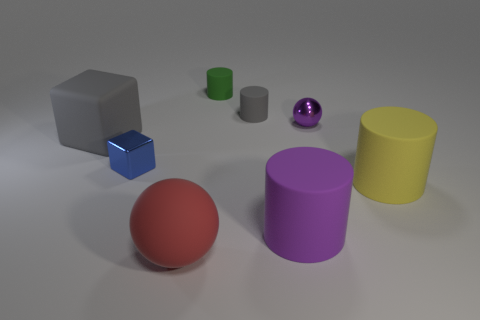Is the shape of the small matte object that is behind the small gray object the same as the tiny shiny thing on the left side of the gray matte cylinder?
Make the answer very short. No. There is a gray matte thing that is the same size as the blue metal thing; what is its shape?
Your response must be concise. Cylinder. What color is the big block that is made of the same material as the red sphere?
Offer a very short reply. Gray. Does the red matte object have the same shape as the metallic object that is on the right side of the big red matte thing?
Provide a short and direct response. Yes. There is a tiny cylinder that is the same color as the large block; what is its material?
Your answer should be very brief. Rubber. There is a gray cylinder that is the same size as the green matte cylinder; what is its material?
Keep it short and to the point. Rubber. Is there a large ball of the same color as the big rubber cube?
Your answer should be very brief. No. There is a large object that is both to the right of the big red thing and to the left of the small purple ball; what is its shape?
Keep it short and to the point. Cylinder. How many large green cubes are made of the same material as the big purple cylinder?
Keep it short and to the point. 0. Is the number of large yellow rubber cylinders to the left of the small green matte thing less than the number of small gray cylinders that are in front of the yellow thing?
Offer a terse response. No. 